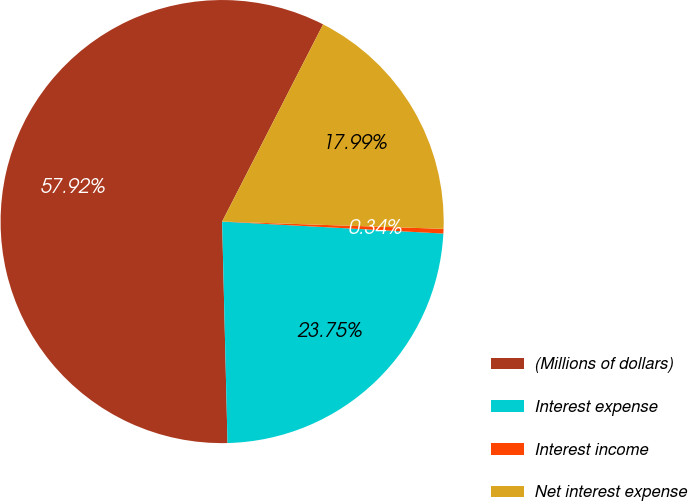Convert chart. <chart><loc_0><loc_0><loc_500><loc_500><pie_chart><fcel>(Millions of dollars)<fcel>Interest expense<fcel>Interest income<fcel>Net interest expense<nl><fcel>57.92%<fcel>23.75%<fcel>0.34%<fcel>17.99%<nl></chart> 